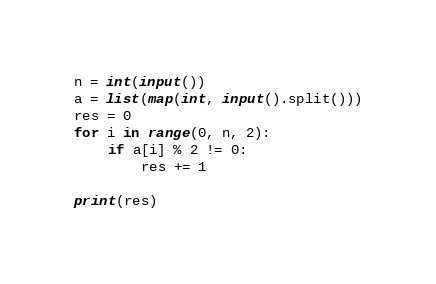Convert code to text. <code><loc_0><loc_0><loc_500><loc_500><_Python_>n = int(input())
a = list(map(int, input().split()))
res = 0
for i in range(0, n, 2):
    if a[i] % 2 != 0:
        res += 1

print(res)
</code> 